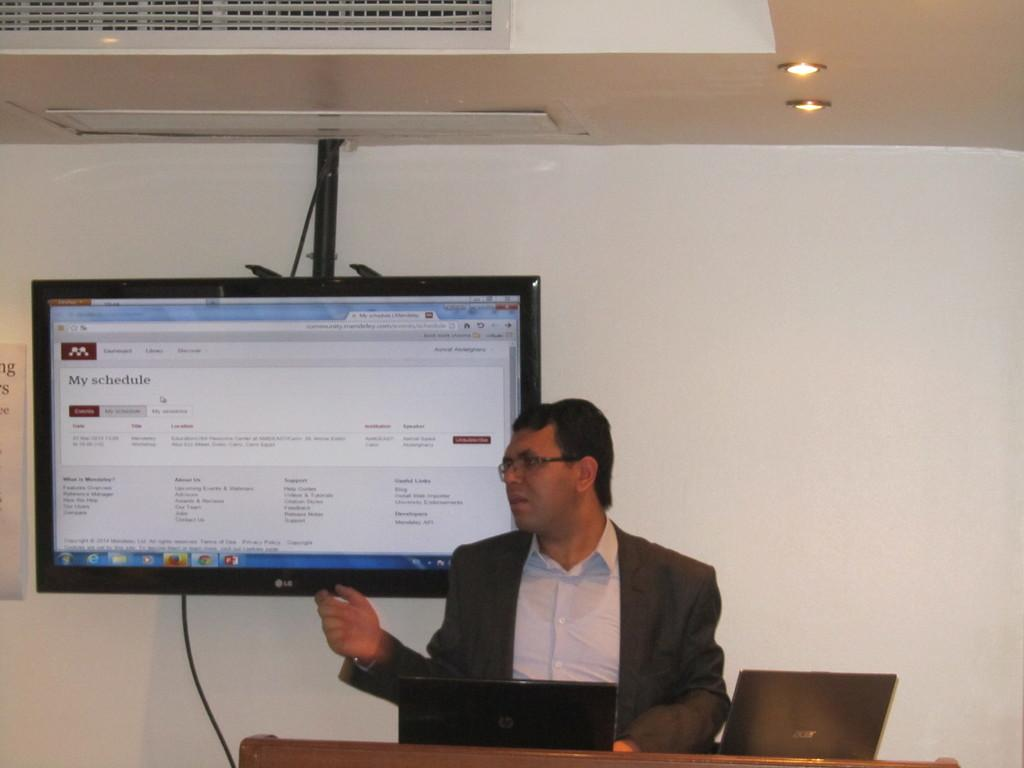<image>
Present a compact description of the photo's key features. a man with his schedule on a television behind him 